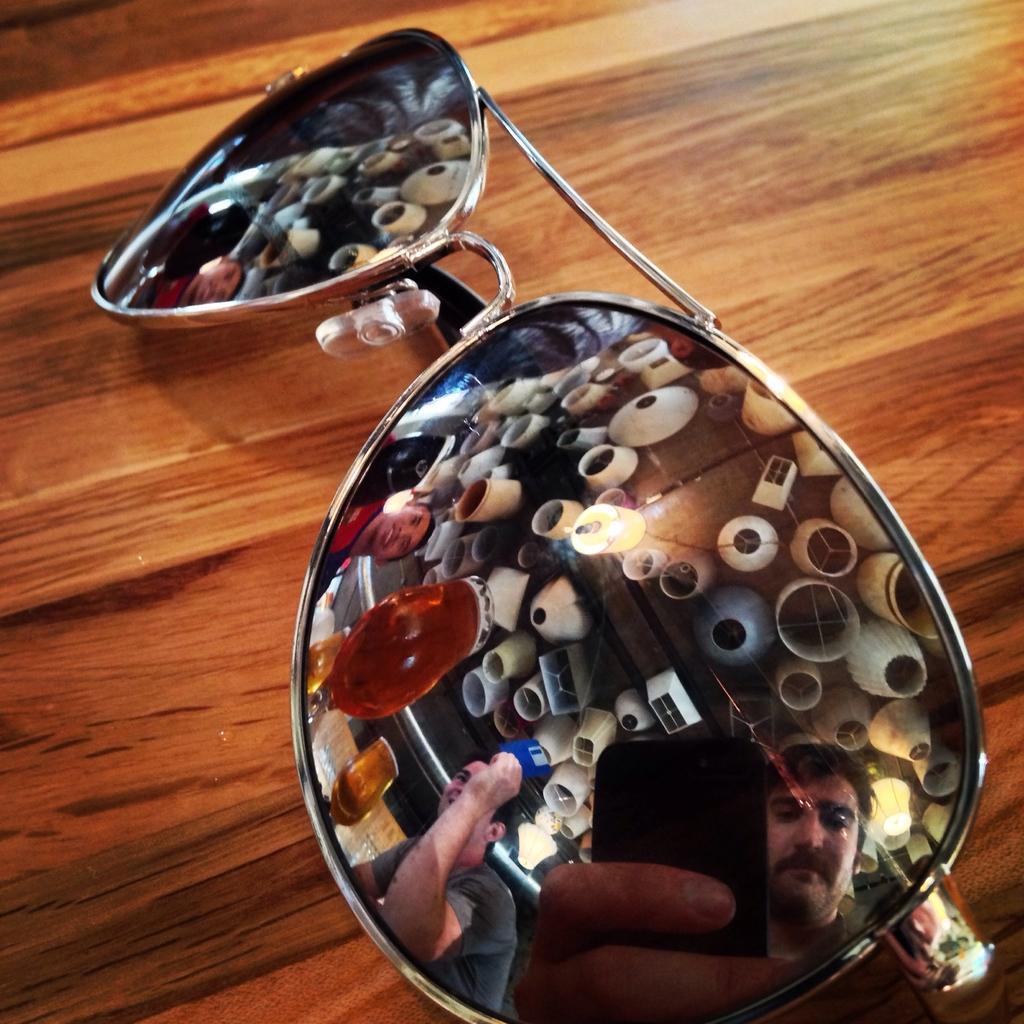Please provide a concise description of this image. In this picture there is a glass kept on the table and we find many objects which are reflecting on the roof are on to the glass. Here a guy is trying to capture the image with a phone. we also observe few decorative items attached to the roof. 